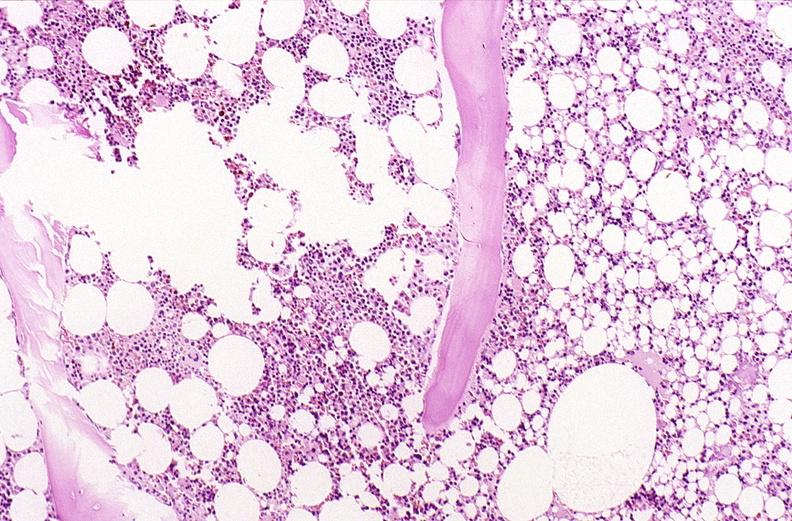what does this image show?
Answer the question using a single word or phrase. Bone 